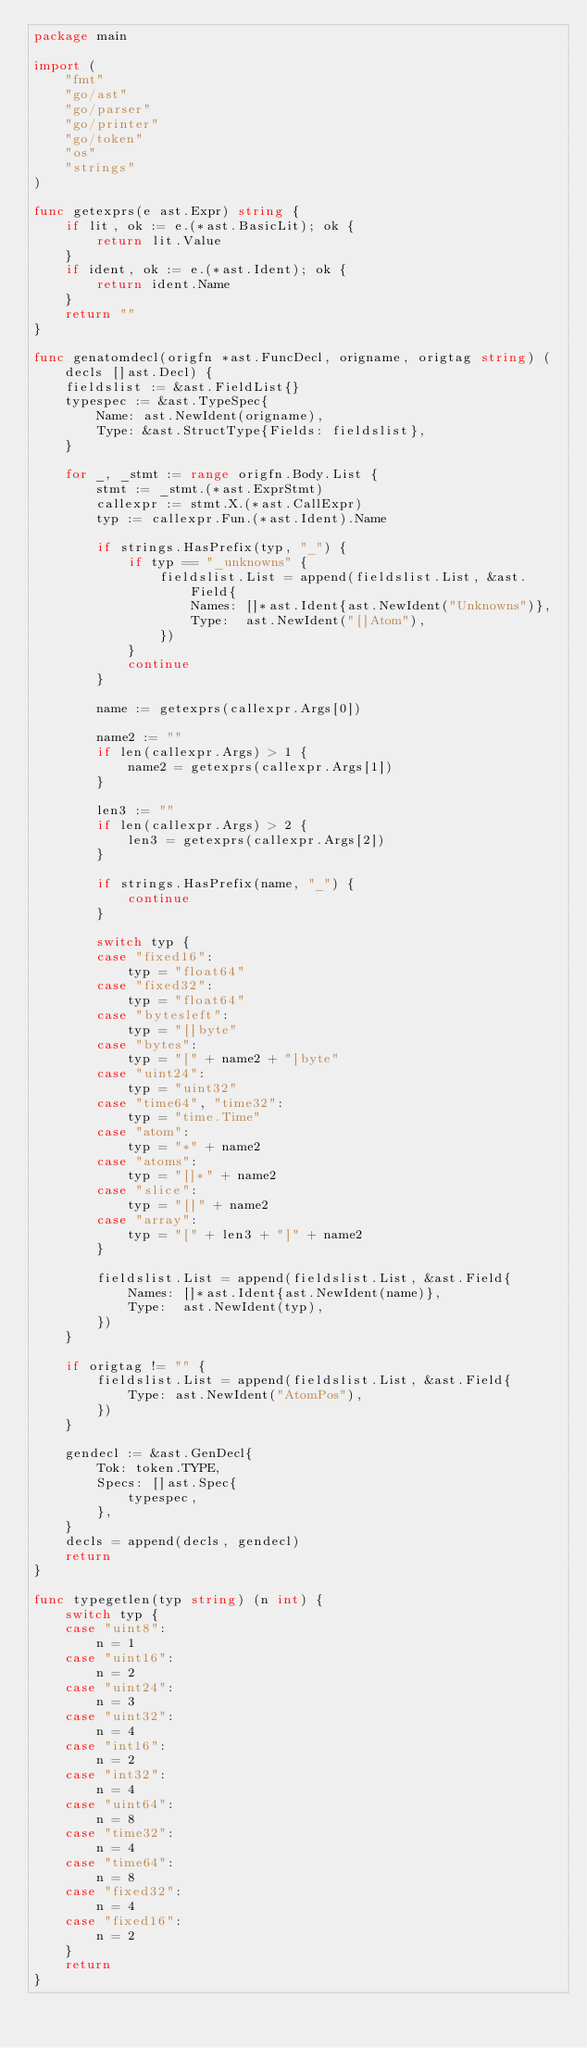<code> <loc_0><loc_0><loc_500><loc_500><_Go_>package main

import (
	"fmt"
	"go/ast"
	"go/parser"
	"go/printer"
	"go/token"
	"os"
	"strings"
)

func getexprs(e ast.Expr) string {
	if lit, ok := e.(*ast.BasicLit); ok {
		return lit.Value
	}
	if ident, ok := e.(*ast.Ident); ok {
		return ident.Name
	}
	return ""
}

func genatomdecl(origfn *ast.FuncDecl, origname, origtag string) (decls []ast.Decl) {
	fieldslist := &ast.FieldList{}
	typespec := &ast.TypeSpec{
		Name: ast.NewIdent(origname),
		Type: &ast.StructType{Fields: fieldslist},
	}

	for _, _stmt := range origfn.Body.List {
		stmt := _stmt.(*ast.ExprStmt)
		callexpr := stmt.X.(*ast.CallExpr)
		typ := callexpr.Fun.(*ast.Ident).Name

		if strings.HasPrefix(typ, "_") {
			if typ == "_unknowns" {
				fieldslist.List = append(fieldslist.List, &ast.Field{
					Names: []*ast.Ident{ast.NewIdent("Unknowns")},
					Type:  ast.NewIdent("[]Atom"),
				})
			}
			continue
		}

		name := getexprs(callexpr.Args[0])

		name2 := ""
		if len(callexpr.Args) > 1 {
			name2 = getexprs(callexpr.Args[1])
		}

		len3 := ""
		if len(callexpr.Args) > 2 {
			len3 = getexprs(callexpr.Args[2])
		}

		if strings.HasPrefix(name, "_") {
			continue
		}

		switch typ {
		case "fixed16":
			typ = "float64"
		case "fixed32":
			typ = "float64"
		case "bytesleft":
			typ = "[]byte"
		case "bytes":
			typ = "[" + name2 + "]byte"
		case "uint24":
			typ = "uint32"
		case "time64", "time32":
			typ = "time.Time"
		case "atom":
			typ = "*" + name2
		case "atoms":
			typ = "[]*" + name2
		case "slice":
			typ = "[]" + name2
		case "array":
			typ = "[" + len3 + "]" + name2
		}

		fieldslist.List = append(fieldslist.List, &ast.Field{
			Names: []*ast.Ident{ast.NewIdent(name)},
			Type:  ast.NewIdent(typ),
		})
	}

	if origtag != "" {
		fieldslist.List = append(fieldslist.List, &ast.Field{
			Type: ast.NewIdent("AtomPos"),
		})
	}

	gendecl := &ast.GenDecl{
		Tok: token.TYPE,
		Specs: []ast.Spec{
			typespec,
		},
	}
	decls = append(decls, gendecl)
	return
}

func typegetlen(typ string) (n int) {
	switch typ {
	case "uint8":
		n = 1
	case "uint16":
		n = 2
	case "uint24":
		n = 3
	case "uint32":
		n = 4
	case "int16":
		n = 2
	case "int32":
		n = 4
	case "uint64":
		n = 8
	case "time32":
		n = 4
	case "time64":
		n = 8
	case "fixed32":
		n = 4
	case "fixed16":
		n = 2
	}
	return
}
</code> 